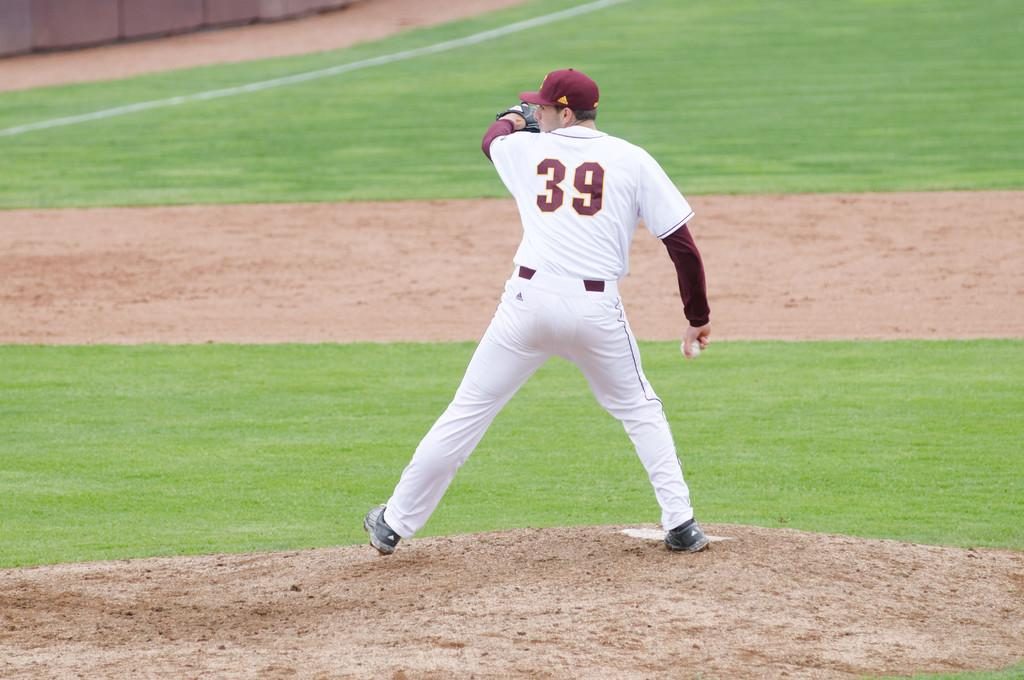Provide a one-sentence caption for the provided image. Player number 39 winds up in preparation to pitch the ball. 